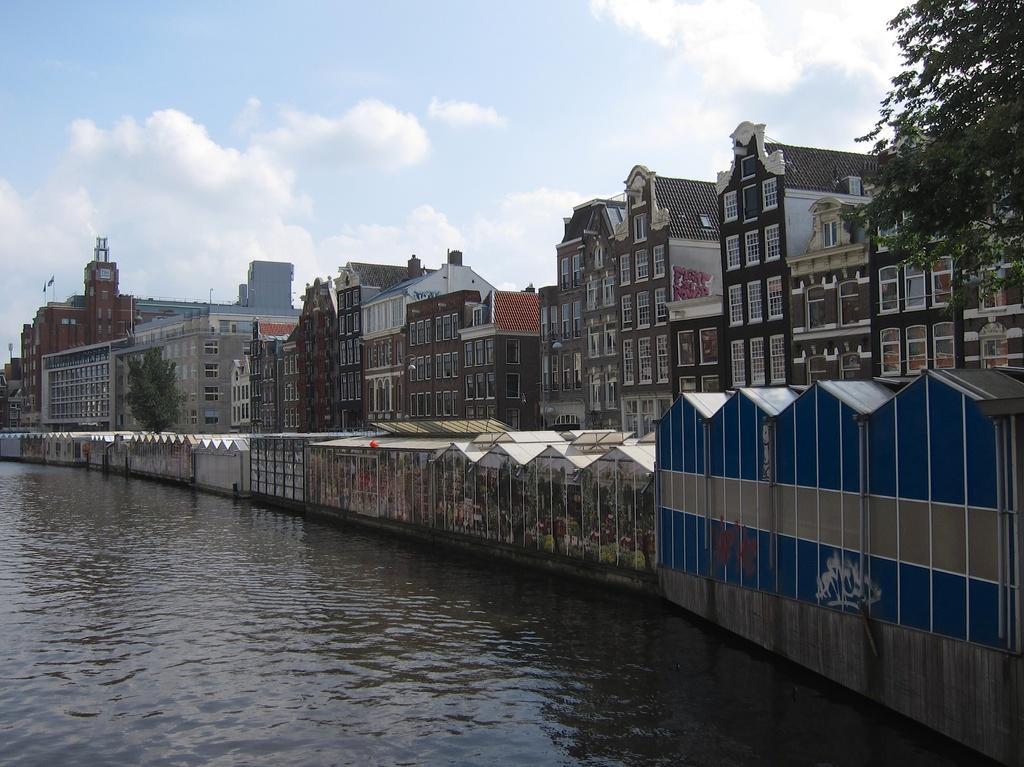Can you describe this image briefly? In this image there is water. There is a wall. There are buildings and trees on the right side. There are clouds in the sky. 